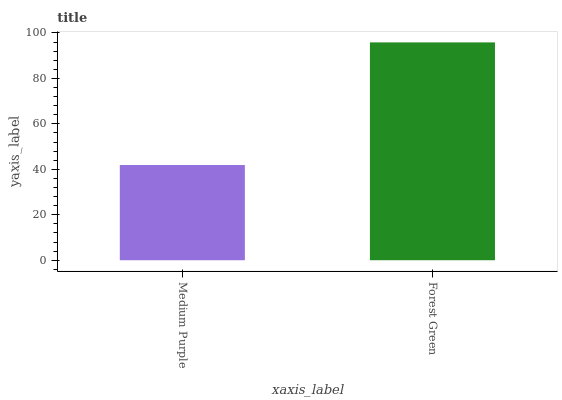Is Medium Purple the minimum?
Answer yes or no. Yes. Is Forest Green the maximum?
Answer yes or no. Yes. Is Forest Green the minimum?
Answer yes or no. No. Is Forest Green greater than Medium Purple?
Answer yes or no. Yes. Is Medium Purple less than Forest Green?
Answer yes or no. Yes. Is Medium Purple greater than Forest Green?
Answer yes or no. No. Is Forest Green less than Medium Purple?
Answer yes or no. No. Is Forest Green the high median?
Answer yes or no. Yes. Is Medium Purple the low median?
Answer yes or no. Yes. Is Medium Purple the high median?
Answer yes or no. No. Is Forest Green the low median?
Answer yes or no. No. 